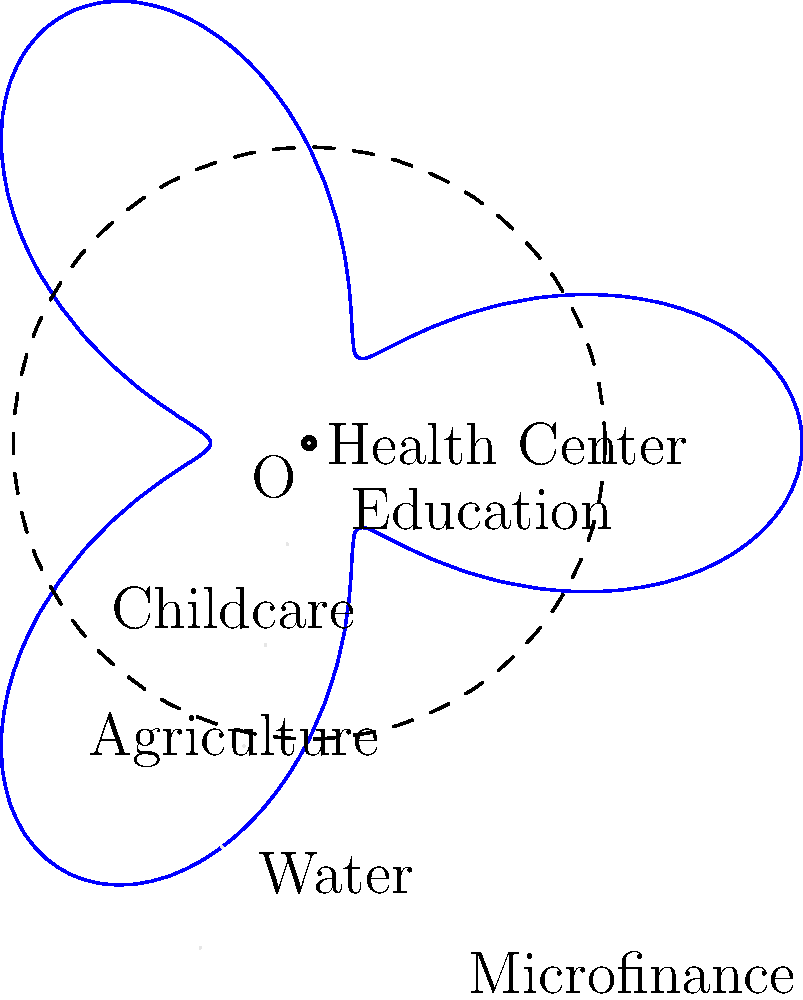The polar graph represents the distribution of resources across a rural community, where the distance from the center indicates the level of investment in each sector. The equation of the curve is $r = 3 + 2\cos(3\theta)$. Which two sectors receive the highest level of investment, and what is the maximum radial distance (rounded to one decimal place) representing this investment? To solve this problem, we need to follow these steps:

1) The equation $r = 3 + 2\cos(3\theta)$ represents the distribution of resources.

2) The maximum value of $r$ occurs when $\cos(3\theta) = 1$, which happens when $3\theta = 0, 2\pi, 4\pi, ...$

3) Solving for $\theta$:
   $\theta = 0, \frac{2\pi}{3}, \frac{4\pi}{3}, ...$

4) These angles correspond to the following sectors:
   $\theta = 0$: Health Center
   $\theta = \frac{2\pi}{3}$: Childcare
   $\theta = \frac{4\pi}{3}$: Water

5) The maximum radial distance is when $r = 3 + 2 = 5$

6) Therefore, the sectors receiving the highest investment are Health Center and Childcare.

7) The maximum radial distance is 5 units.
Answer: Health Center and Childcare; 5.0 units 